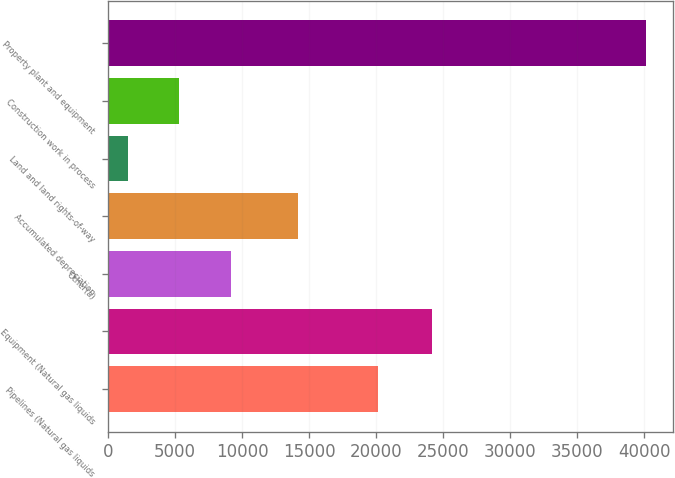<chart> <loc_0><loc_0><loc_500><loc_500><bar_chart><fcel>Pipelines (Natural gas liquids<fcel>Equipment (Natural gas liquids<fcel>Other(a)<fcel>Accumulated depreciation<fcel>Land and land rights-of-way<fcel>Construction work in process<fcel>Property plant and equipment<nl><fcel>20157<fcel>24152<fcel>9195.8<fcel>14175<fcel>1456<fcel>5325.9<fcel>40155<nl></chart> 